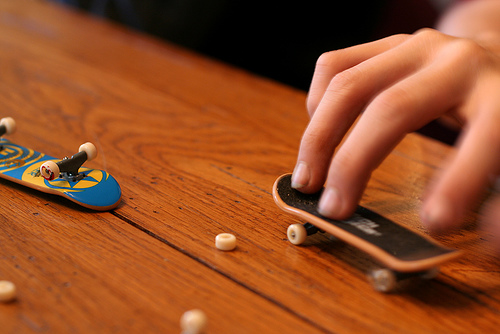<image>
Is there a skateboard in the finger? No. The skateboard is not contained within the finger. These objects have a different spatial relationship. 